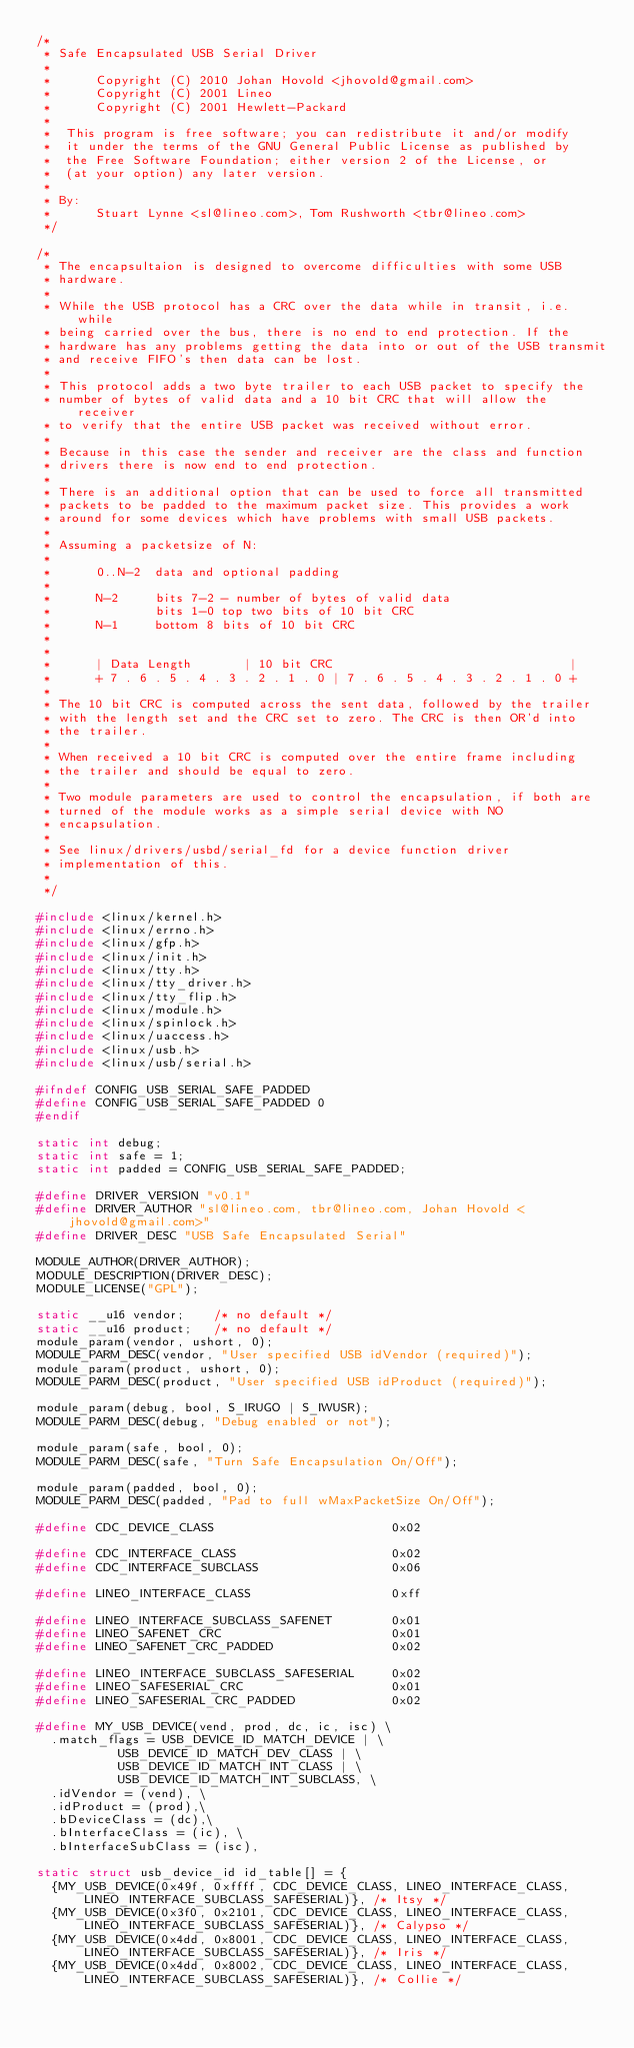Convert code to text. <code><loc_0><loc_0><loc_500><loc_500><_C_>/*
 * Safe Encapsulated USB Serial Driver
 *
 *      Copyright (C) 2010 Johan Hovold <jhovold@gmail.com>
 *      Copyright (C) 2001 Lineo
 *      Copyright (C) 2001 Hewlett-Packard
 *
 *	This program is free software; you can redistribute it and/or modify
 *	it under the terms of the GNU General Public License as published by
 *	the Free Software Foundation; either version 2 of the License, or
 *	(at your option) any later version.
 *
 * By:
 *      Stuart Lynne <sl@lineo.com>, Tom Rushworth <tbr@lineo.com>
 */

/*
 * The encapsultaion is designed to overcome difficulties with some USB
 * hardware.
 *
 * While the USB protocol has a CRC over the data while in transit, i.e. while
 * being carried over the bus, there is no end to end protection. If the
 * hardware has any problems getting the data into or out of the USB transmit
 * and receive FIFO's then data can be lost.
 *
 * This protocol adds a two byte trailer to each USB packet to specify the
 * number of bytes of valid data and a 10 bit CRC that will allow the receiver
 * to verify that the entire USB packet was received without error.
 *
 * Because in this case the sender and receiver are the class and function
 * drivers there is now end to end protection.
 *
 * There is an additional option that can be used to force all transmitted
 * packets to be padded to the maximum packet size. This provides a work
 * around for some devices which have problems with small USB packets.
 *
 * Assuming a packetsize of N:
 *
 *      0..N-2  data and optional padding
 *
 *      N-2     bits 7-2 - number of bytes of valid data
 *              bits 1-0 top two bits of 10 bit CRC
 *      N-1     bottom 8 bits of 10 bit CRC
 *
 *
 *      | Data Length       | 10 bit CRC                                |
 *      + 7 . 6 . 5 . 4 . 3 . 2 . 1 . 0 | 7 . 6 . 5 . 4 . 3 . 2 . 1 . 0 +
 *
 * The 10 bit CRC is computed across the sent data, followed by the trailer
 * with the length set and the CRC set to zero. The CRC is then OR'd into
 * the trailer.
 *
 * When received a 10 bit CRC is computed over the entire frame including
 * the trailer and should be equal to zero.
 *
 * Two module parameters are used to control the encapsulation, if both are
 * turned of the module works as a simple serial device with NO
 * encapsulation.
 *
 * See linux/drivers/usbd/serial_fd for a device function driver
 * implementation of this.
 *
 */

#include <linux/kernel.h>
#include <linux/errno.h>
#include <linux/gfp.h>
#include <linux/init.h>
#include <linux/tty.h>
#include <linux/tty_driver.h>
#include <linux/tty_flip.h>
#include <linux/module.h>
#include <linux/spinlock.h>
#include <linux/uaccess.h>
#include <linux/usb.h>
#include <linux/usb/serial.h>

#ifndef CONFIG_USB_SERIAL_SAFE_PADDED
#define CONFIG_USB_SERIAL_SAFE_PADDED 0
#endif

static int debug;
static int safe = 1;
static int padded = CONFIG_USB_SERIAL_SAFE_PADDED;

#define DRIVER_VERSION "v0.1"
#define DRIVER_AUTHOR "sl@lineo.com, tbr@lineo.com, Johan Hovold <jhovold@gmail.com>"
#define DRIVER_DESC "USB Safe Encapsulated Serial"

MODULE_AUTHOR(DRIVER_AUTHOR);
MODULE_DESCRIPTION(DRIVER_DESC);
MODULE_LICENSE("GPL");

static __u16 vendor;		/* no default */
static __u16 product;		/* no default */
module_param(vendor, ushort, 0);
MODULE_PARM_DESC(vendor, "User specified USB idVendor (required)");
module_param(product, ushort, 0);
MODULE_PARM_DESC(product, "User specified USB idProduct (required)");

module_param(debug, bool, S_IRUGO | S_IWUSR);
MODULE_PARM_DESC(debug, "Debug enabled or not");

module_param(safe, bool, 0);
MODULE_PARM_DESC(safe, "Turn Safe Encapsulation On/Off");

module_param(padded, bool, 0);
MODULE_PARM_DESC(padded, "Pad to full wMaxPacketSize On/Off");

#define CDC_DEVICE_CLASS                        0x02

#define CDC_INTERFACE_CLASS                     0x02
#define CDC_INTERFACE_SUBCLASS                  0x06

#define LINEO_INTERFACE_CLASS                   0xff

#define LINEO_INTERFACE_SUBCLASS_SAFENET        0x01
#define LINEO_SAFENET_CRC                       0x01
#define LINEO_SAFENET_CRC_PADDED                0x02

#define LINEO_INTERFACE_SUBCLASS_SAFESERIAL     0x02
#define LINEO_SAFESERIAL_CRC                    0x01
#define LINEO_SAFESERIAL_CRC_PADDED             0x02

#define MY_USB_DEVICE(vend, prod, dc, ic, isc) \
	.match_flags = USB_DEVICE_ID_MATCH_DEVICE | \
		       USB_DEVICE_ID_MATCH_DEV_CLASS | \
		       USB_DEVICE_ID_MATCH_INT_CLASS | \
		       USB_DEVICE_ID_MATCH_INT_SUBCLASS, \
	.idVendor = (vend), \
	.idProduct = (prod),\
	.bDeviceClass = (dc),\
	.bInterfaceClass = (ic), \
	.bInterfaceSubClass = (isc),

static struct usb_device_id id_table[] = {
	{MY_USB_DEVICE(0x49f, 0xffff, CDC_DEVICE_CLASS, LINEO_INTERFACE_CLASS, LINEO_INTERFACE_SUBCLASS_SAFESERIAL)},	/* Itsy */
	{MY_USB_DEVICE(0x3f0, 0x2101, CDC_DEVICE_CLASS, LINEO_INTERFACE_CLASS, LINEO_INTERFACE_SUBCLASS_SAFESERIAL)},	/* Calypso */
	{MY_USB_DEVICE(0x4dd, 0x8001, CDC_DEVICE_CLASS, LINEO_INTERFACE_CLASS, LINEO_INTERFACE_SUBCLASS_SAFESERIAL)},	/* Iris */
	{MY_USB_DEVICE(0x4dd, 0x8002, CDC_DEVICE_CLASS, LINEO_INTERFACE_CLASS, LINEO_INTERFACE_SUBCLASS_SAFESERIAL)},	/* Collie */</code> 